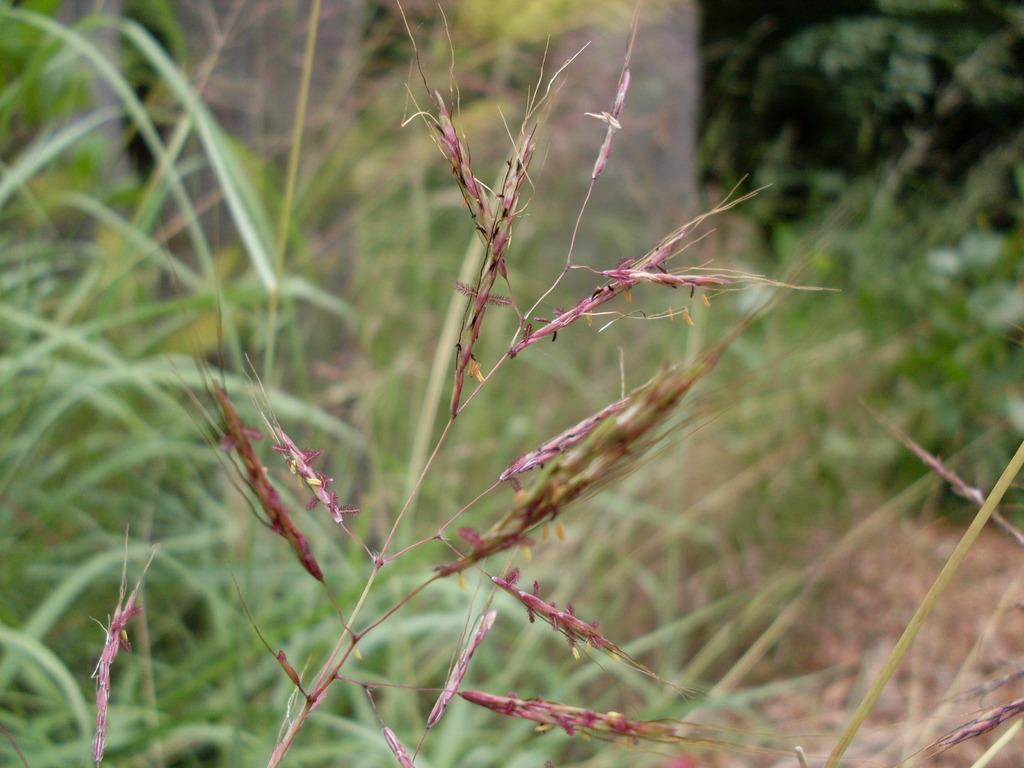What type of vegetation is visible in the image? There is grass in the image. How many police officers are visible in the image? There are no police officers present in the image; it only features grass. What type of sticks can be seen in the image? There are no sticks visible in the image; it only features grass. 